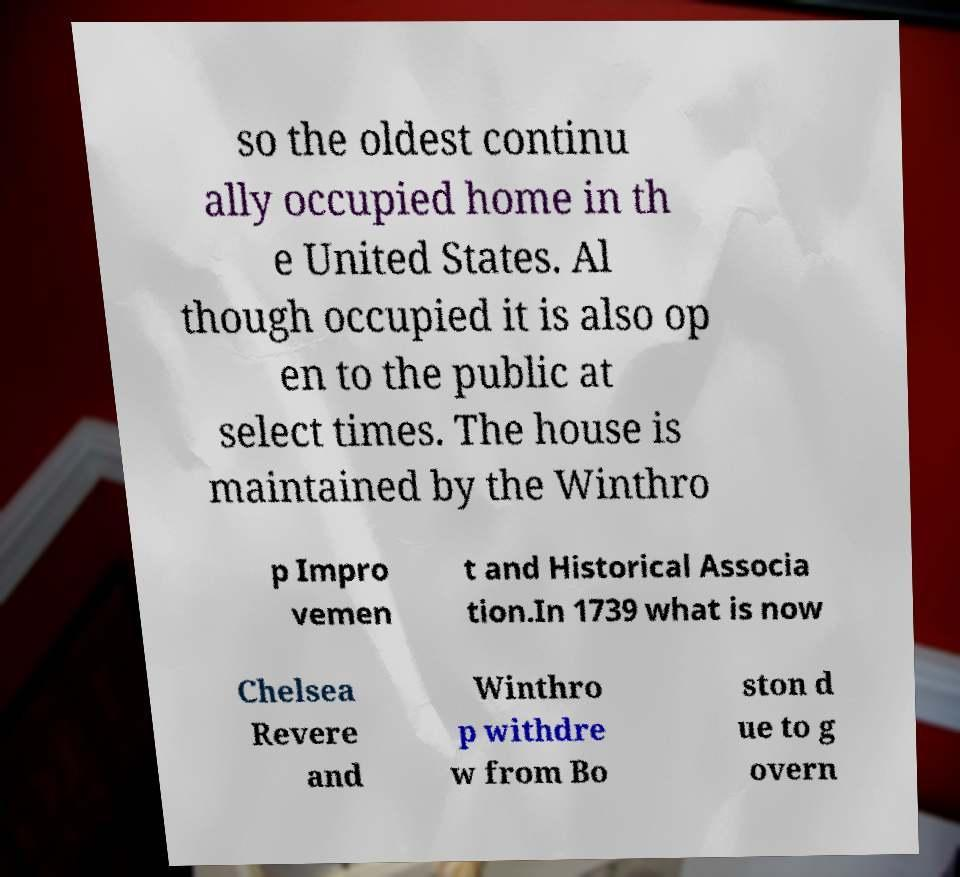What messages or text are displayed in this image? I need them in a readable, typed format. so the oldest continu ally occupied home in th e United States. Al though occupied it is also op en to the public at select times. The house is maintained by the Winthro p Impro vemen t and Historical Associa tion.In 1739 what is now Chelsea Revere and Winthro p withdre w from Bo ston d ue to g overn 